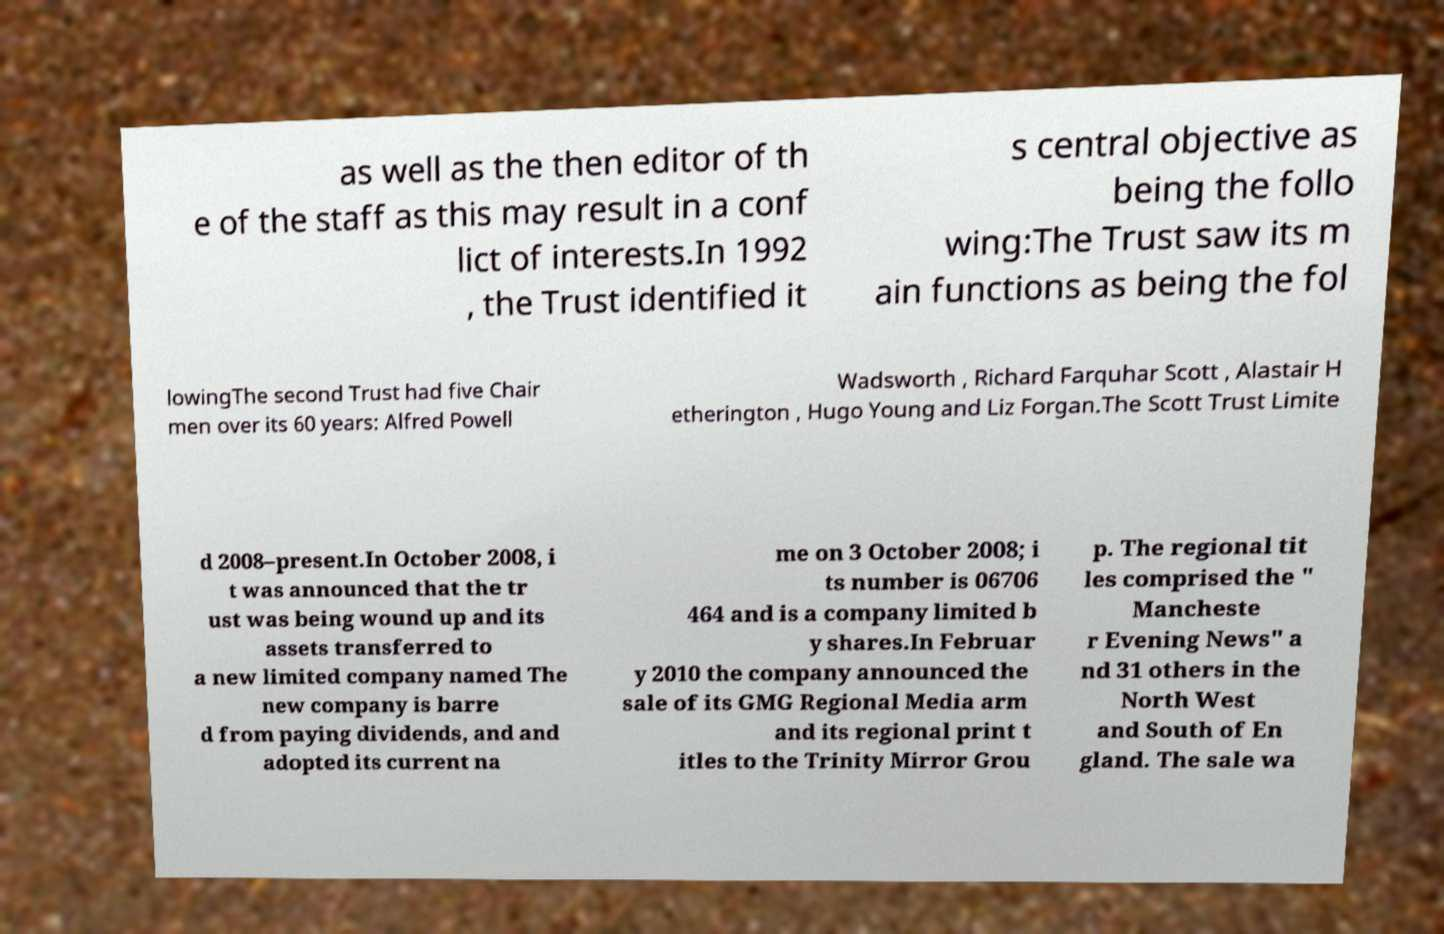Please identify and transcribe the text found in this image. as well as the then editor of th e of the staff as this may result in a conf lict of interests.In 1992 , the Trust identified it s central objective as being the follo wing:The Trust saw its m ain functions as being the fol lowingThe second Trust had five Chair men over its 60 years: Alfred Powell Wadsworth , Richard Farquhar Scott , Alastair H etherington , Hugo Young and Liz Forgan.The Scott Trust Limite d 2008–present.In October 2008, i t was announced that the tr ust was being wound up and its assets transferred to a new limited company named The new company is barre d from paying dividends, and and adopted its current na me on 3 October 2008; i ts number is 06706 464 and is a company limited b y shares.In Februar y 2010 the company announced the sale of its GMG Regional Media arm and its regional print t itles to the Trinity Mirror Grou p. The regional tit les comprised the " Mancheste r Evening News" a nd 31 others in the North West and South of En gland. The sale wa 